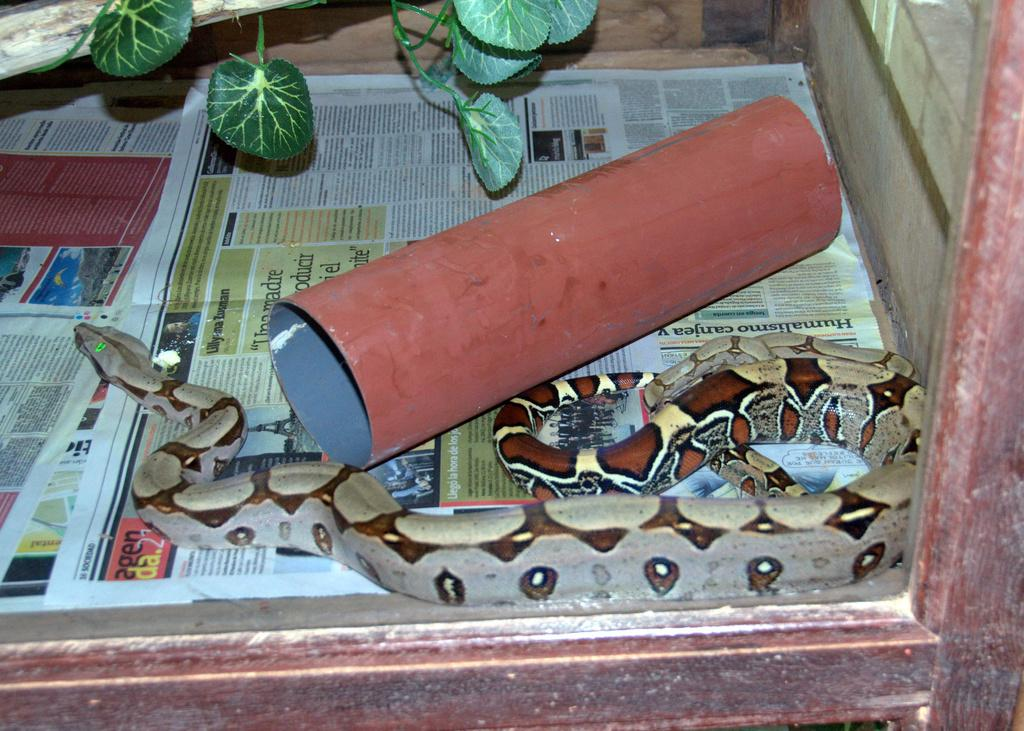What type of animal is present in the image? There is a snake in the image. What other objects can be seen in the image? There are news papers and a pole visible in the image. What type of plant is in a glass container in the image? There is a plant in a glass container in the image. How many eggs are visible in the image? There are no eggs present in the image. What type of twig is the snake using to ask a question in the image? There is no twig or any indication of a question being asked in the image. 